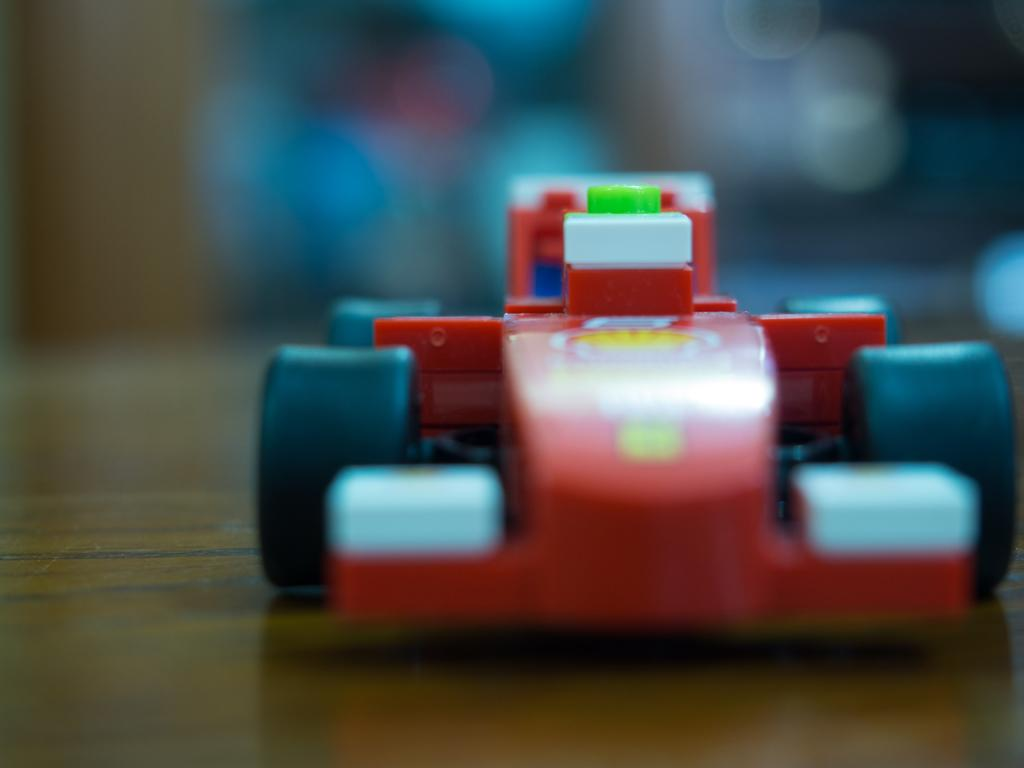What object is the main focus of the image? There is a toy car in the image. Where is the toy car located? The toy car is placed on a table. What is the color of the table? The table is brown in color. What colors can be seen on the toy car? The toy car has red and blue colors. How would you describe the background of the image? The background of the image is blurred. What type of lunch is being served in the image? There is no lunch present in the image; it features a toy car on a table. Can you hear any bells ringing in the image? There are no bells or sounds mentioned in the image, as it is a still image of a toy car on a table. 